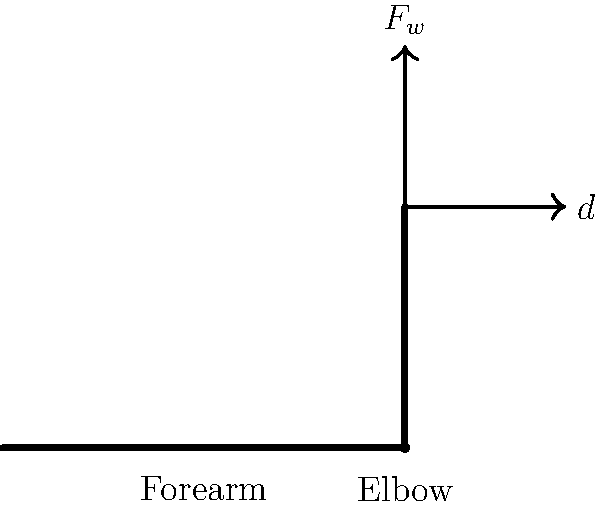A PHP developer is taking a break from coding to do some bicep curls. If the weight of the dumbbell is 15 N and the perpendicular distance from the elbow joint to the line of action of the weight is 30 cm, what is the magnitude of the torque generated at the elbow joint? To calculate the torque generated at the elbow joint during a bicep curl, we need to use the formula for torque:

$$\tau = F \times d$$

Where:
$\tau$ = torque
$F$ = force (weight of the dumbbell)
$d$ = perpendicular distance from the axis of rotation (elbow joint) to the line of action of the force

Given:
- Weight of the dumbbell ($F$) = 15 N
- Perpendicular distance ($d$) = 30 cm = 0.3 m

Step 1: Substitute the values into the torque formula
$$\tau = F \times d$$
$$\tau = 15 \text{ N} \times 0.3 \text{ m}$$

Step 2: Calculate the torque
$$\tau = 4.5 \text{ N}\cdot\text{m}$$

The magnitude of the torque generated at the elbow joint is 4.5 N·m.
Answer: 4.5 N·m 